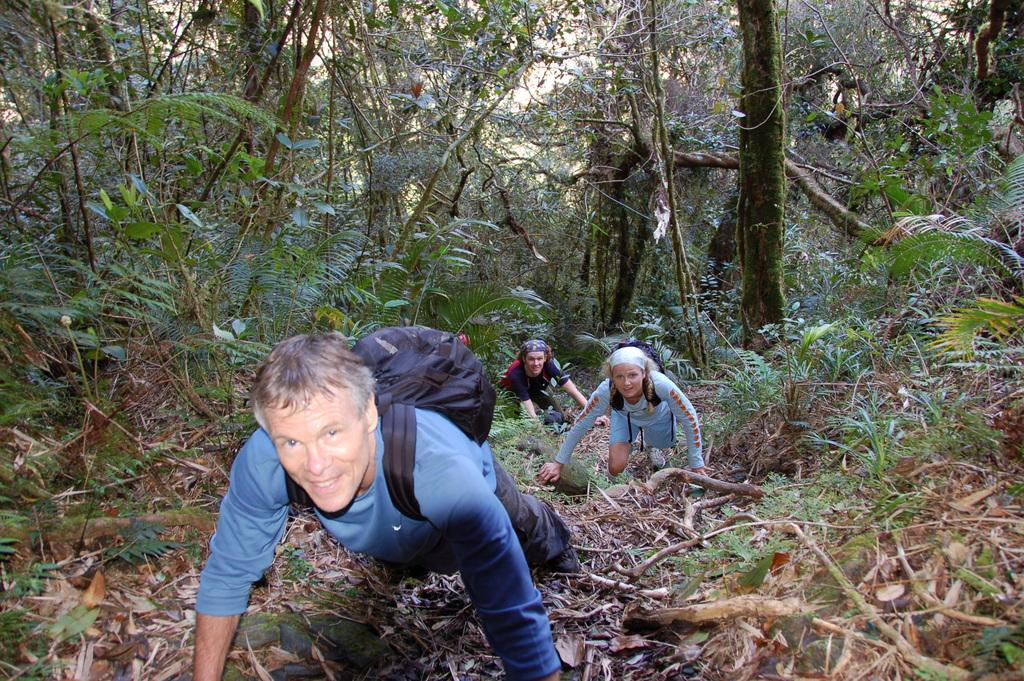Can you describe this image briefly? In this image we can see people wearing bags and we can also see trees and plants. 